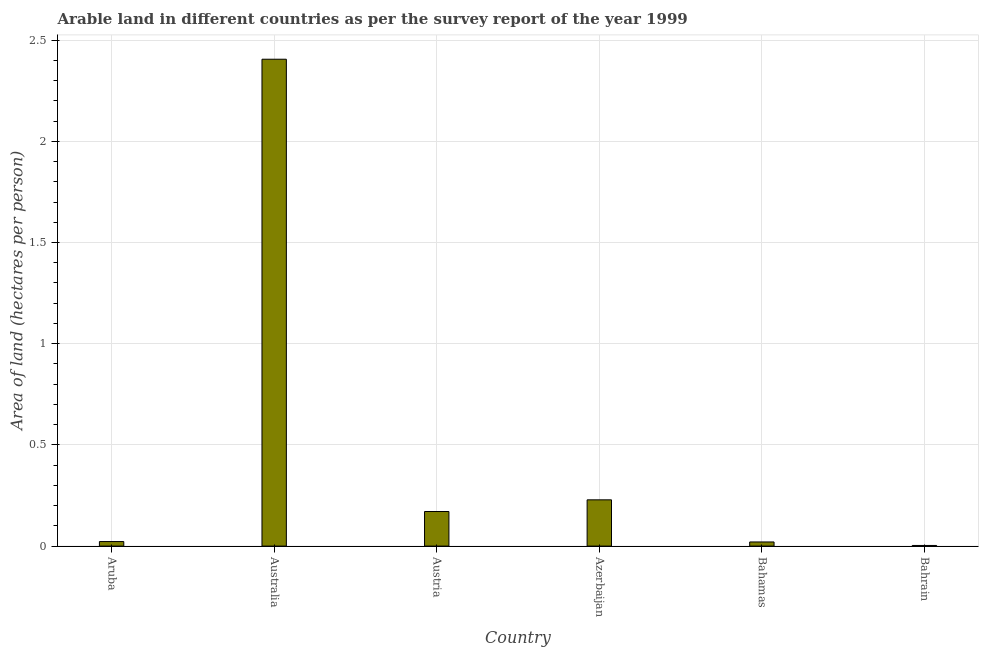Does the graph contain any zero values?
Your response must be concise. No. What is the title of the graph?
Your response must be concise. Arable land in different countries as per the survey report of the year 1999. What is the label or title of the Y-axis?
Provide a succinct answer. Area of land (hectares per person). What is the area of arable land in Austria?
Your answer should be compact. 0.17. Across all countries, what is the maximum area of arable land?
Offer a very short reply. 2.41. Across all countries, what is the minimum area of arable land?
Ensure brevity in your answer.  0. In which country was the area of arable land minimum?
Ensure brevity in your answer.  Bahrain. What is the sum of the area of arable land?
Your response must be concise. 2.85. What is the difference between the area of arable land in Australia and Azerbaijan?
Offer a terse response. 2.18. What is the average area of arable land per country?
Your answer should be very brief. 0.47. What is the median area of arable land?
Offer a very short reply. 0.1. In how many countries, is the area of arable land greater than 1.3 hectares per person?
Provide a succinct answer. 1. What is the ratio of the area of arable land in Aruba to that in Bahrain?
Ensure brevity in your answer.  7.2. What is the difference between the highest and the second highest area of arable land?
Your response must be concise. 2.18. Is the sum of the area of arable land in Austria and Bahamas greater than the maximum area of arable land across all countries?
Your answer should be very brief. No. What is the difference between the highest and the lowest area of arable land?
Give a very brief answer. 2.4. In how many countries, is the area of arable land greater than the average area of arable land taken over all countries?
Give a very brief answer. 1. Are all the bars in the graph horizontal?
Your response must be concise. No. What is the Area of land (hectares per person) in Aruba?
Your response must be concise. 0.02. What is the Area of land (hectares per person) of Australia?
Make the answer very short. 2.41. What is the Area of land (hectares per person) of Austria?
Provide a short and direct response. 0.17. What is the Area of land (hectares per person) of Azerbaijan?
Offer a terse response. 0.23. What is the Area of land (hectares per person) of Bahamas?
Give a very brief answer. 0.02. What is the Area of land (hectares per person) of Bahrain?
Your answer should be compact. 0. What is the difference between the Area of land (hectares per person) in Aruba and Australia?
Your answer should be compact. -2.38. What is the difference between the Area of land (hectares per person) in Aruba and Austria?
Ensure brevity in your answer.  -0.15. What is the difference between the Area of land (hectares per person) in Aruba and Azerbaijan?
Your response must be concise. -0.21. What is the difference between the Area of land (hectares per person) in Aruba and Bahamas?
Provide a short and direct response. 0. What is the difference between the Area of land (hectares per person) in Aruba and Bahrain?
Give a very brief answer. 0.02. What is the difference between the Area of land (hectares per person) in Australia and Austria?
Provide a succinct answer. 2.23. What is the difference between the Area of land (hectares per person) in Australia and Azerbaijan?
Make the answer very short. 2.18. What is the difference between the Area of land (hectares per person) in Australia and Bahamas?
Ensure brevity in your answer.  2.39. What is the difference between the Area of land (hectares per person) in Australia and Bahrain?
Offer a very short reply. 2.4. What is the difference between the Area of land (hectares per person) in Austria and Azerbaijan?
Provide a short and direct response. -0.06. What is the difference between the Area of land (hectares per person) in Austria and Bahamas?
Your answer should be compact. 0.15. What is the difference between the Area of land (hectares per person) in Austria and Bahrain?
Ensure brevity in your answer.  0.17. What is the difference between the Area of land (hectares per person) in Azerbaijan and Bahamas?
Ensure brevity in your answer.  0.21. What is the difference between the Area of land (hectares per person) in Azerbaijan and Bahrain?
Provide a short and direct response. 0.23. What is the difference between the Area of land (hectares per person) in Bahamas and Bahrain?
Offer a very short reply. 0.02. What is the ratio of the Area of land (hectares per person) in Aruba to that in Australia?
Offer a very short reply. 0.01. What is the ratio of the Area of land (hectares per person) in Aruba to that in Austria?
Give a very brief answer. 0.13. What is the ratio of the Area of land (hectares per person) in Aruba to that in Azerbaijan?
Offer a very short reply. 0.1. What is the ratio of the Area of land (hectares per person) in Aruba to that in Bahamas?
Provide a succinct answer. 1.1. What is the ratio of the Area of land (hectares per person) in Aruba to that in Bahrain?
Your answer should be very brief. 7.2. What is the ratio of the Area of land (hectares per person) in Australia to that in Austria?
Offer a very short reply. 14.07. What is the ratio of the Area of land (hectares per person) in Australia to that in Azerbaijan?
Provide a short and direct response. 10.52. What is the ratio of the Area of land (hectares per person) in Australia to that in Bahamas?
Ensure brevity in your answer.  117.71. What is the ratio of the Area of land (hectares per person) in Australia to that in Bahrain?
Offer a terse response. 770.91. What is the ratio of the Area of land (hectares per person) in Austria to that in Azerbaijan?
Ensure brevity in your answer.  0.75. What is the ratio of the Area of land (hectares per person) in Austria to that in Bahamas?
Your answer should be compact. 8.36. What is the ratio of the Area of land (hectares per person) in Austria to that in Bahrain?
Give a very brief answer. 54.77. What is the ratio of the Area of land (hectares per person) in Azerbaijan to that in Bahamas?
Provide a succinct answer. 11.19. What is the ratio of the Area of land (hectares per person) in Azerbaijan to that in Bahrain?
Ensure brevity in your answer.  73.26. What is the ratio of the Area of land (hectares per person) in Bahamas to that in Bahrain?
Make the answer very short. 6.55. 